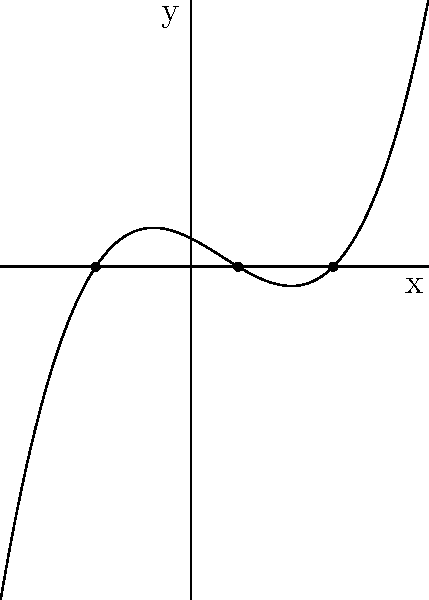As a novelist exploring phonetics for character development, consider the polynomial function $f(x) = 0.1(x+2)(x-1)(x-3)$, which could represent the tonal range of a character's voice. Sketch the graph of this function and determine its end behavior. How might this polynomial's shape inform the emotional arc of a character in your novel? Let's approach this step-by-step:

1) First, identify the roots of the polynomial:
   The factors are $(x+2)$, $(x-1)$, and $(x-3)$
   So, the roots are $x = -2$, $x = 1$, and $x = 3$

2) The leading coefficient is positive (0.1), so the end behavior will be:
   As $x \to +\infty$, $f(x) \to +\infty$
   As $x \to -\infty$, $f(x) \to -\infty$

3) Sketch the graph:
   - Plot the roots: (-2,0), (1,0), and (3,0)
   - The graph will cross the x-axis at these points
   - Since the degree is odd (3) and the leading coefficient is positive, 
     the graph will start in the negative y region and end in the positive y region

4) The shape of the graph:
   - Starts in the third quadrant, crosses at x = -2
   - Rises to a local maximum between -2 and 1
   - Crosses again at x = 1, dips to a local minimum between 1 and 3
   - Crosses one last time at x = 3, then rises indefinitely

5) Character development interpretation:
   The graph could represent a character's emotional journey. The roots could be pivotal moments in the story, while the rises and falls between roots could represent emotional highs and lows. The end behavior suggests an ultimately positive resolution or character growth.
Answer: The graph crosses the x-axis at (-2,0), (1,0), and (3,0). It has positive end behavior as $x \to +\infty$ and negative end behavior as $x \to -\infty$. This shape could represent a character's emotional journey with three significant events and an ultimately positive resolution. 